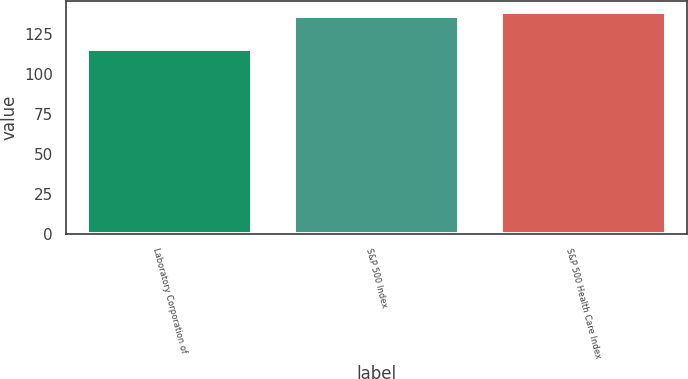Convert chart. <chart><loc_0><loc_0><loc_500><loc_500><bar_chart><fcel>Laboratory Corporation of<fcel>S&P 500 Index<fcel>S&P 500 Health Care Index<nl><fcel>115.74<fcel>136.3<fcel>138.4<nl></chart> 